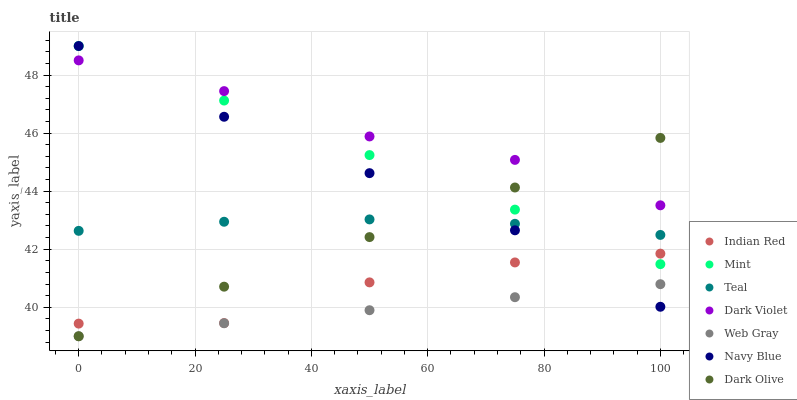Does Web Gray have the minimum area under the curve?
Answer yes or no. Yes. Does Dark Violet have the maximum area under the curve?
Answer yes or no. Yes. Does Indian Red have the minimum area under the curve?
Answer yes or no. No. Does Indian Red have the maximum area under the curve?
Answer yes or no. No. Is Web Gray the smoothest?
Answer yes or no. Yes. Is Indian Red the roughest?
Answer yes or no. Yes. Is Navy Blue the smoothest?
Answer yes or no. No. Is Navy Blue the roughest?
Answer yes or no. No. Does Web Gray have the lowest value?
Answer yes or no. Yes. Does Indian Red have the lowest value?
Answer yes or no. No. Does Mint have the highest value?
Answer yes or no. Yes. Does Indian Red have the highest value?
Answer yes or no. No. Is Web Gray less than Dark Violet?
Answer yes or no. Yes. Is Indian Red greater than Web Gray?
Answer yes or no. Yes. Does Navy Blue intersect Teal?
Answer yes or no. Yes. Is Navy Blue less than Teal?
Answer yes or no. No. Is Navy Blue greater than Teal?
Answer yes or no. No. Does Web Gray intersect Dark Violet?
Answer yes or no. No. 